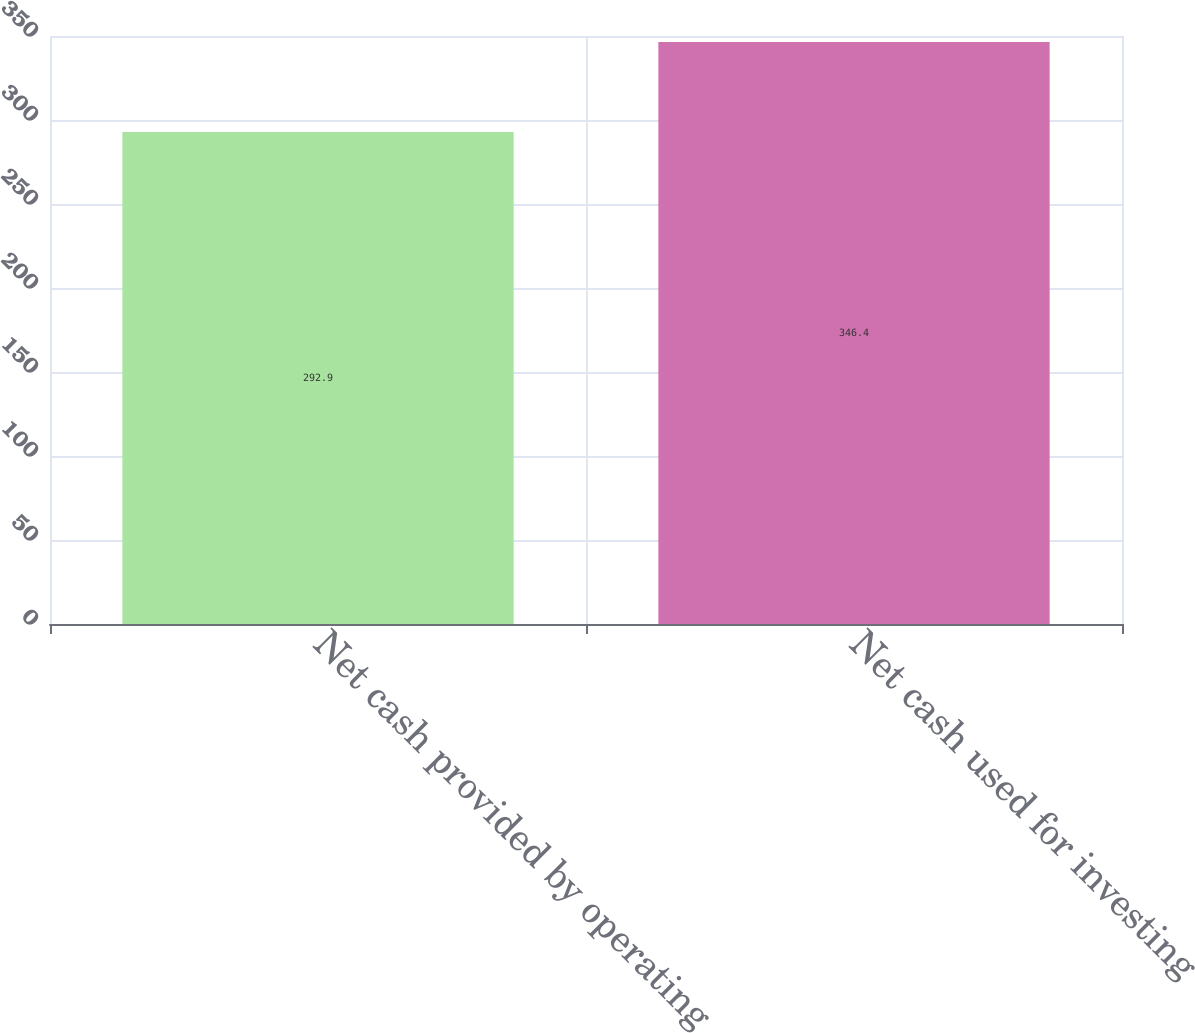<chart> <loc_0><loc_0><loc_500><loc_500><bar_chart><fcel>Net cash provided by operating<fcel>Net cash used for investing<nl><fcel>292.9<fcel>346.4<nl></chart> 